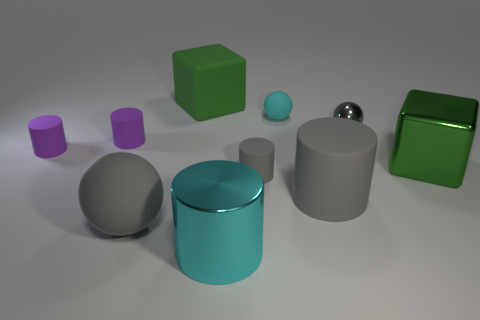There is a gray metallic thing; is it the same size as the matte ball that is to the right of the large gray ball?
Offer a terse response. Yes. How many metal things are either big balls or large gray cylinders?
Give a very brief answer. 0. Are there more metal spheres than big brown spheres?
Make the answer very short. Yes. What is the size of the matte object that is the same color as the shiny block?
Your answer should be very brief. Large. The big object right of the large gray thing that is right of the large matte block is what shape?
Make the answer very short. Cube. There is a large matte thing that is behind the cyan object that is right of the big shiny cylinder; are there any gray things behind it?
Keep it short and to the point. No. What color is the metal block that is the same size as the gray rubber ball?
Ensure brevity in your answer.  Green. What is the shape of the large matte object that is both to the left of the metal cylinder and in front of the rubber cube?
Ensure brevity in your answer.  Sphere. What size is the gray sphere that is on the right side of the big green block that is behind the metal ball?
Your response must be concise. Small. How many metallic cubes are the same color as the metallic ball?
Your answer should be compact. 0. 